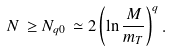<formula> <loc_0><loc_0><loc_500><loc_500>N \, \geq N _ { q 0 } \, \simeq 2 \left ( \ln \frac { M } { m _ { T } } \right ) ^ { q } .</formula> 